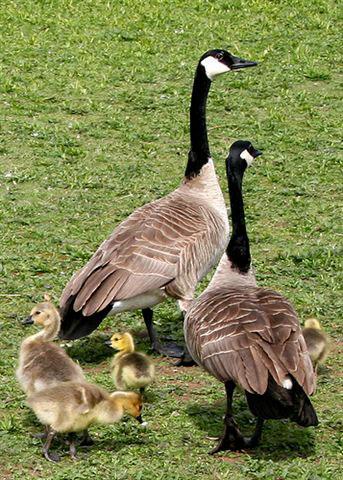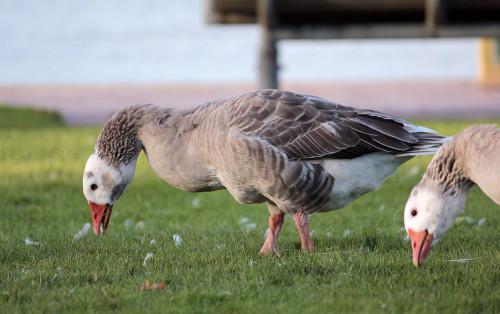The first image is the image on the left, the second image is the image on the right. For the images shown, is this caption "The combined images include two geese with grey coloring bending their grey necks toward the grass." true? Answer yes or no. Yes. The first image is the image on the left, the second image is the image on the right. Assess this claim about the two images: "The right image contains exactly one duck.". Correct or not? Answer yes or no. No. 